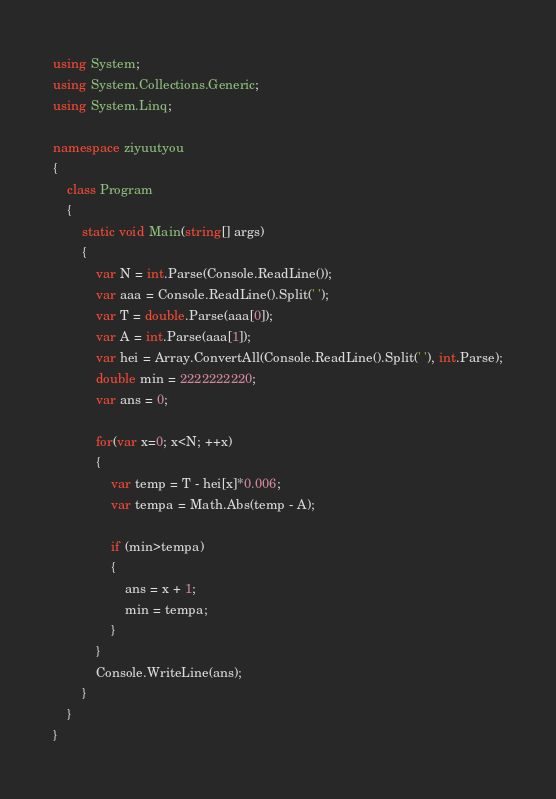<code> <loc_0><loc_0><loc_500><loc_500><_C#_>using System;
using System.Collections.Generic;
using System.Linq;

namespace ziyuutyou
{
    class Program
    {
        static void Main(string[] args)
        {
            var N = int.Parse(Console.ReadLine());
            var aaa = Console.ReadLine().Split(' ');
            var T = double.Parse(aaa[0]);
            var A = int.Parse(aaa[1]);
            var hei = Array.ConvertAll(Console.ReadLine().Split(' '), int.Parse);
            double min = 2222222220;
            var ans = 0;

            for(var x=0; x<N; ++x)
            {
                var temp = T - hei[x]*0.006;
                var tempa = Math.Abs(temp - A);

                if (min>tempa)
                {
                    ans = x + 1;
                    min = tempa;
                }
            }
            Console.WriteLine(ans);
        }
    }
}
</code> 